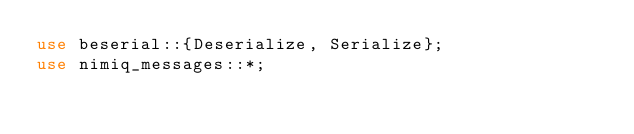Convert code to text. <code><loc_0><loc_0><loc_500><loc_500><_Rust_>use beserial::{Deserialize, Serialize};
use nimiq_messages::*;
</code> 